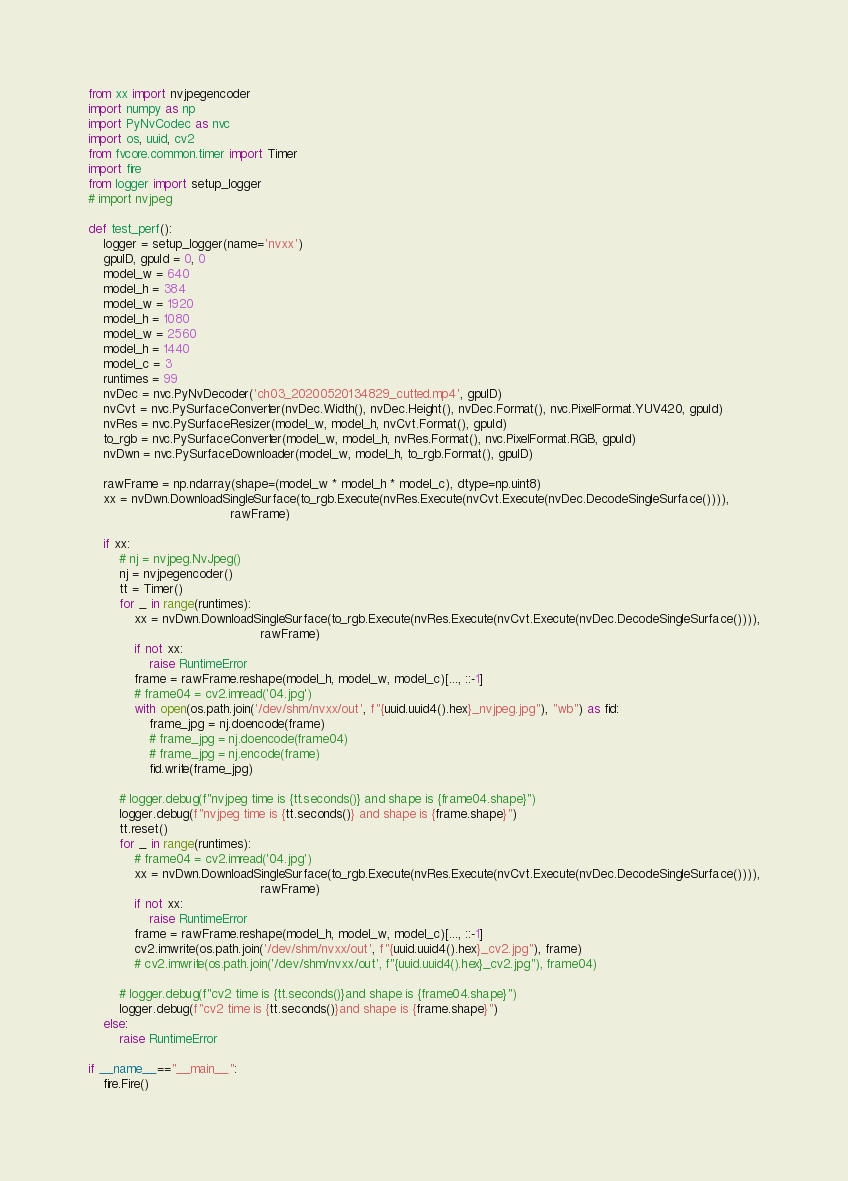<code> <loc_0><loc_0><loc_500><loc_500><_Python_>from xx import nvjpegencoder
import numpy as np
import PyNvCodec as nvc
import os, uuid, cv2
from fvcore.common.timer import Timer
import fire
from logger import setup_logger
# import nvjpeg

def test_perf():
    logger = setup_logger(name='nvxx')
    gpuID, gpuId = 0, 0
    model_w = 640
    model_h = 384
    model_w = 1920
    model_h = 1080
    model_w = 2560
    model_h = 1440
    model_c = 3
    runtimes = 99
    nvDec = nvc.PyNvDecoder('ch03_20200520134829_cutted.mp4', gpuID)
    nvCvt = nvc.PySurfaceConverter(nvDec.Width(), nvDec.Height(), nvDec.Format(), nvc.PixelFormat.YUV420, gpuId)
    nvRes = nvc.PySurfaceResizer(model_w, model_h, nvCvt.Format(), gpuId)
    to_rgb = nvc.PySurfaceConverter(model_w, model_h, nvRes.Format(), nvc.PixelFormat.RGB, gpuId)
    nvDwn = nvc.PySurfaceDownloader(model_w, model_h, to_rgb.Format(), gpuID)

    rawFrame = np.ndarray(shape=(model_w * model_h * model_c), dtype=np.uint8)
    xx = nvDwn.DownloadSingleSurface(to_rgb.Execute(nvRes.Execute(nvCvt.Execute(nvDec.DecodeSingleSurface()))),
                                     rawFrame)

    if xx:
        # nj = nvjpeg.NvJpeg()
        nj = nvjpegencoder()
        tt = Timer()
        for _ in range(runtimes):
            xx = nvDwn.DownloadSingleSurface(to_rgb.Execute(nvRes.Execute(nvCvt.Execute(nvDec.DecodeSingleSurface()))),
                                             rawFrame)
            if not xx:
                raise RuntimeError
            frame = rawFrame.reshape(model_h, model_w, model_c)[..., ::-1]
            # frame04 = cv2.imread('04.jpg')
            with open(os.path.join('/dev/shm/nvxx/out', f"{uuid.uuid4().hex}_nvjpeg.jpg"), "wb") as fid:
                frame_jpg = nj.doencode(frame)
                # frame_jpg = nj.doencode(frame04)
                # frame_jpg = nj.encode(frame)
                fid.write(frame_jpg)

        # logger.debug(f"nvjpeg time is {tt.seconds()} and shape is {frame04.shape}")
        logger.debug(f"nvjpeg time is {tt.seconds()} and shape is {frame.shape}")
        tt.reset()
        for _ in range(runtimes):
            # frame04 = cv2.imread('04.jpg')
            xx = nvDwn.DownloadSingleSurface(to_rgb.Execute(nvRes.Execute(nvCvt.Execute(nvDec.DecodeSingleSurface()))),
                                             rawFrame)
            if not xx:
                raise RuntimeError
            frame = rawFrame.reshape(model_h, model_w, model_c)[..., ::-1]
            cv2.imwrite(os.path.join('/dev/shm/nvxx/out', f"{uuid.uuid4().hex}_cv2.jpg"), frame)
            # cv2.imwrite(os.path.join('/dev/shm/nvxx/out', f"{uuid.uuid4().hex}_cv2.jpg"), frame04)

        # logger.debug(f"cv2 time is {tt.seconds()}and shape is {frame04.shape}")
        logger.debug(f"cv2 time is {tt.seconds()}and shape is {frame.shape}")
    else:
        raise RuntimeError

if __name__=="__main__":
    fire.Fire()
</code> 